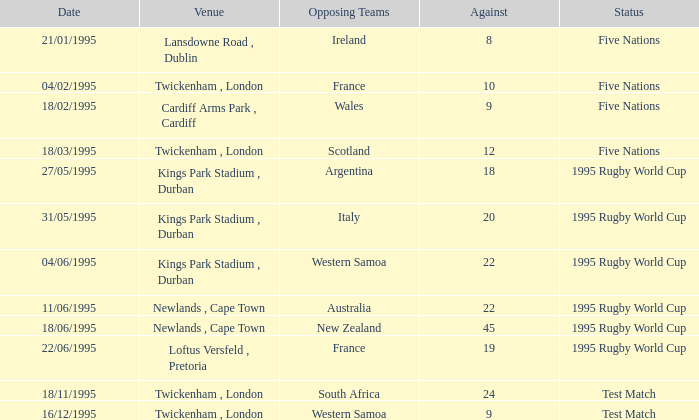What's the status on 16/12/1995? Test Match. 